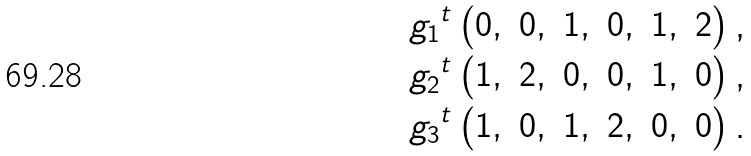<formula> <loc_0><loc_0><loc_500><loc_500>g _ { 1 } & ^ { t } \begin{pmatrix} 0 , & 0 , & 1 , & 0 , & 1 , & 2 \end{pmatrix} , \\ g _ { 2 } & ^ { t } \begin{pmatrix} 1 , & 2 , & 0 , & 0 , & 1 , & 0 \end{pmatrix} , \\ g _ { 3 } & ^ { t } \begin{pmatrix} 1 , & 0 , & 1 , & 2 , & 0 , & 0 \end{pmatrix} .</formula> 